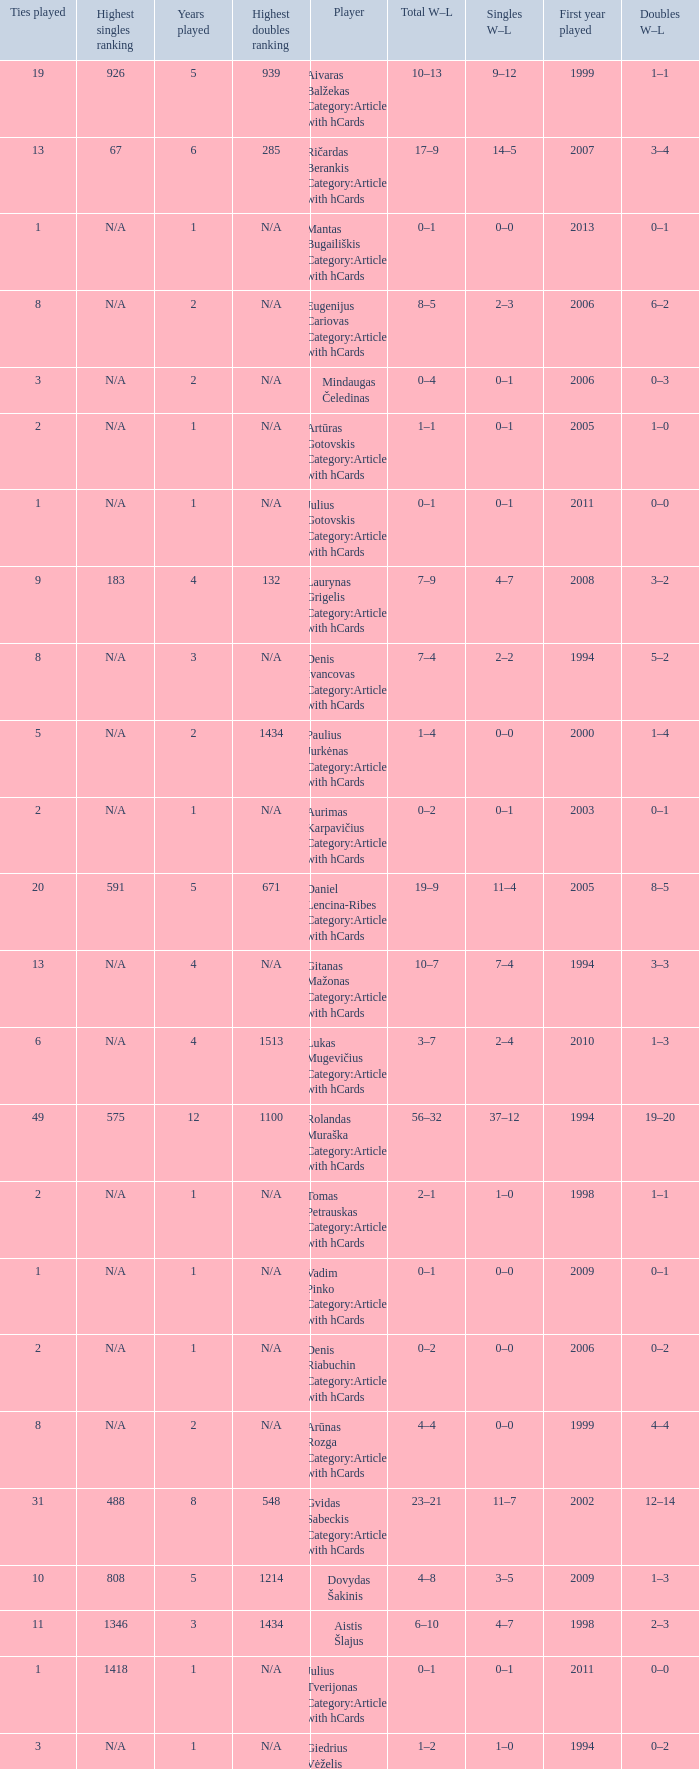Parse the full table. {'header': ['Ties played', 'Highest singles ranking', 'Years played', 'Highest doubles ranking', 'Player', 'Total W–L', 'Singles W–L', 'First year played', 'Doubles W–L'], 'rows': [['19', '926', '5', '939', 'Aivaras Balžekas Category:Articles with hCards', '10–13', '9–12', '1999', '1–1'], ['13', '67', '6', '285', 'Ričardas Berankis Category:Articles with hCards', '17–9', '14–5', '2007', '3–4'], ['1', 'N/A', '1', 'N/A', 'Mantas Bugailiškis Category:Articles with hCards', '0–1', '0–0', '2013', '0–1'], ['8', 'N/A', '2', 'N/A', 'Eugenijus Cariovas Category:Articles with hCards', '8–5', '2–3', '2006', '6–2'], ['3', 'N/A', '2', 'N/A', 'Mindaugas Čeledinas', '0–4', '0–1', '2006', '0–3'], ['2', 'N/A', '1', 'N/A', 'Artūras Gotovskis Category:Articles with hCards', '1–1', '0–1', '2005', '1–0'], ['1', 'N/A', '1', 'N/A', 'Julius Gotovskis Category:Articles with hCards', '0–1', '0–1', '2011', '0–0'], ['9', '183', '4', '132', 'Laurynas Grigelis Category:Articles with hCards', '7–9', '4–7', '2008', '3–2'], ['8', 'N/A', '3', 'N/A', 'Denis Ivancovas Category:Articles with hCards', '7–4', '2–2', '1994', '5–2'], ['5', 'N/A', '2', '1434', 'Paulius Jurkėnas Category:Articles with hCards', '1–4', '0–0', '2000', '1–4'], ['2', 'N/A', '1', 'N/A', 'Aurimas Karpavičius Category:Articles with hCards', '0–2', '0–1', '2003', '0–1'], ['20', '591', '5', '671', 'Daniel Lencina-Ribes Category:Articles with hCards', '19–9', '11–4', '2005', '8–5'], ['13', 'N/A', '4', 'N/A', 'Gitanas Mažonas Category:Articles with hCards', '10–7', '7–4', '1994', '3–3'], ['6', 'N/A', '4', '1513', 'Lukas Mugevičius Category:Articles with hCards', '3–7', '2–4', '2010', '1–3'], ['49', '575', '12', '1100', 'Rolandas Muraška Category:Articles with hCards', '56–32', '37–12', '1994', '19–20'], ['2', 'N/A', '1', 'N/A', 'Tomas Petrauskas Category:Articles with hCards', '2–1', '1–0', '1998', '1–1'], ['1', 'N/A', '1', 'N/A', 'Vadim Pinko Category:Articles with hCards', '0–1', '0–0', '2009', '0–1'], ['2', 'N/A', '1', 'N/A', 'Denis Riabuchin Category:Articles with hCards', '0–2', '0–0', '2006', '0–2'], ['8', 'N/A', '2', 'N/A', 'Arūnas Rozga Category:Articles with hCards', '4–4', '0–0', '1999', '4–4'], ['31', '488', '8', '548', 'Gvidas Sabeckis Category:Articles with hCards', '23–21', '11–7', '2002', '12–14'], ['10', '808', '5', '1214', 'Dovydas Šakinis', '4–8', '3–5', '2009', '1–3'], ['11', '1346', '3', '1434', 'Aistis Šlajus', '6–10', '4–7', '1998', '2–3'], ['1', '1418', '1', 'N/A', 'Julius Tverijonas Category:Articles with hCards', '0–1', '0–1', '2011', '0–0'], ['3', 'N/A', '1', 'N/A', 'Giedrius Vėželis Category:Articles with hCards', '1–2', '1–0', '1994', '0–2']]} Name the minimum tiesplayed for 6 years 13.0. 